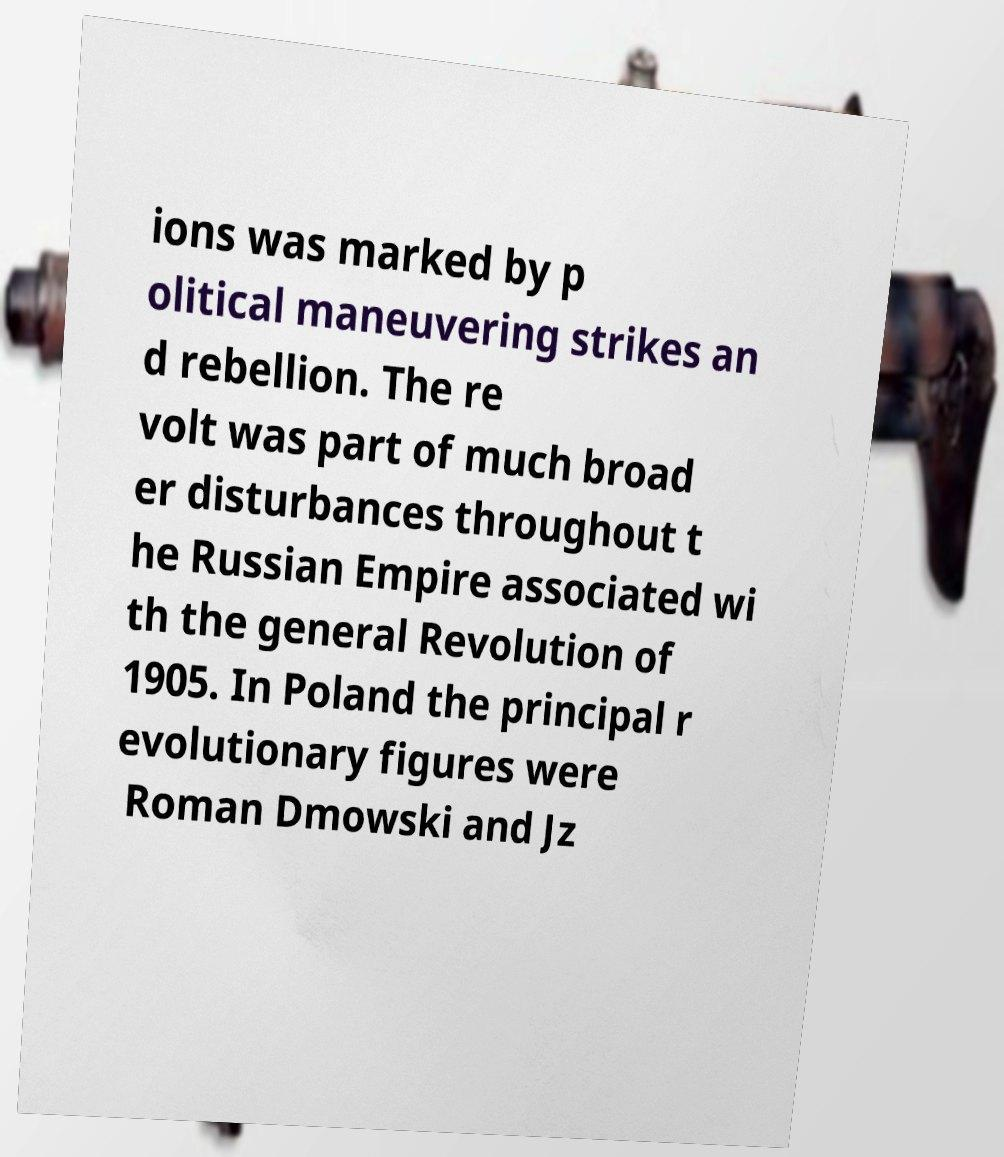Could you extract and type out the text from this image? ions was marked by p olitical maneuvering strikes an d rebellion. The re volt was part of much broad er disturbances throughout t he Russian Empire associated wi th the general Revolution of 1905. In Poland the principal r evolutionary figures were Roman Dmowski and Jz 